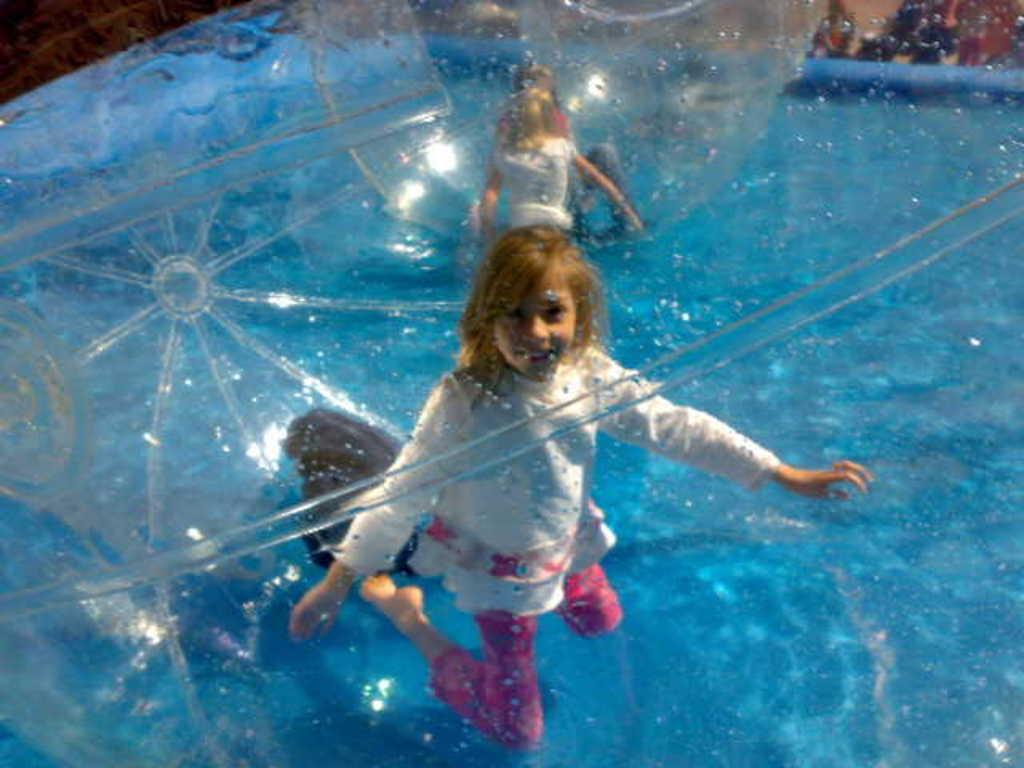Who is present in the image? There are kids in the image. What objects are also visible in the image? Inflatable balls are present in the image. Where are the kids and inflatable balls located? They are on the surface of water. What type of hen can be seen in the image? There is no hen present in the image. What color is the patch on the inflatable ball? There is no patch visible on the inflatable balls in the image. 